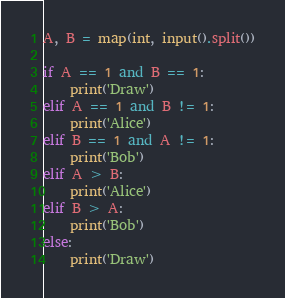<code> <loc_0><loc_0><loc_500><loc_500><_Python_>A, B = map(int, input().split())

if A == 1 and B == 1:
    print('Draw')
elif A == 1 and B != 1:
    print('Alice')
elif B == 1 and A != 1:
    print('Bob')
elif A > B:
    print('Alice')
elif B > A:
    print('Bob')
else:
    print('Draw')
</code> 